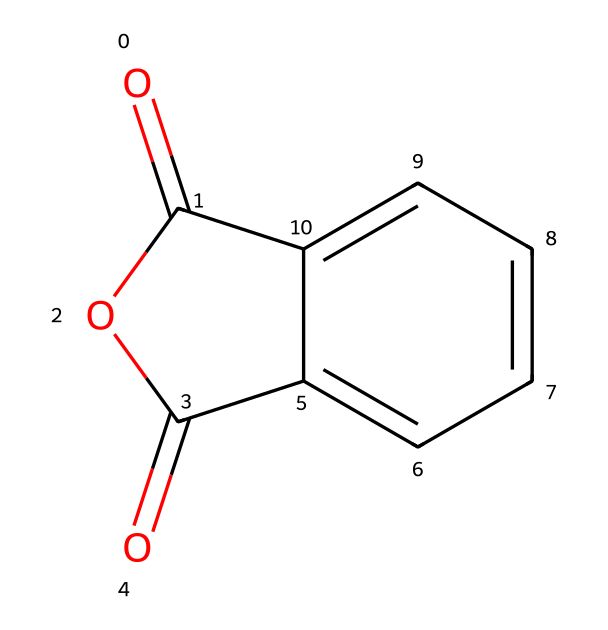What is the molecular formula of phthalic anhydride? To find the molecular formula, you can count the number of different atoms represented in the SMILES. We identify 8 carbon (C) atoms and 4 oxygen (O) atoms. Hence, the molecular formula is C8H4O3.
Answer: C8H4O3 How many rings are present in phthalic anhydride? Upon examining the structure, it can be observed that there is one cyclic component and one anhydride ring. This indicates that there is a total of 2 rings in the molecule.
Answer: 2 What functional groups are present in phthalic anhydride? The chemical structure contains an anhydride functional group as well as a carboxylic acid component. Given the presence of the carbonyl and cyclic structure, we conclude there is an anhydride.
Answer: anhydride Is phthalic anhydride soluble in water? Phthalic anhydride is known to have limited solubility in water due to its hydrophobic aromatic structure.
Answer: limited solubility What type of reaction can phthalic anhydride undergo with alcohols? Phthalic anhydride readily undergoes esterification reactions with alcohols, forming esters as a product. This is a characteristic reaction for anhydrides.
Answer: esterification How many double bonds are present in the chemical structure? In the SMILES representation, we can identify the carbonyl (C=O) functionalities and a double bond in the aromatic ring, which totals to 4 double bonds overall.
Answer: 4 What is the role of phthalic anhydride in dyes used in athletic clothing? Phthalic anhydride acts as a key precursor or intermediate in the synthesis of synthetic dyes used in fabrics, contributing to the dye's properties.
Answer: key precursor 